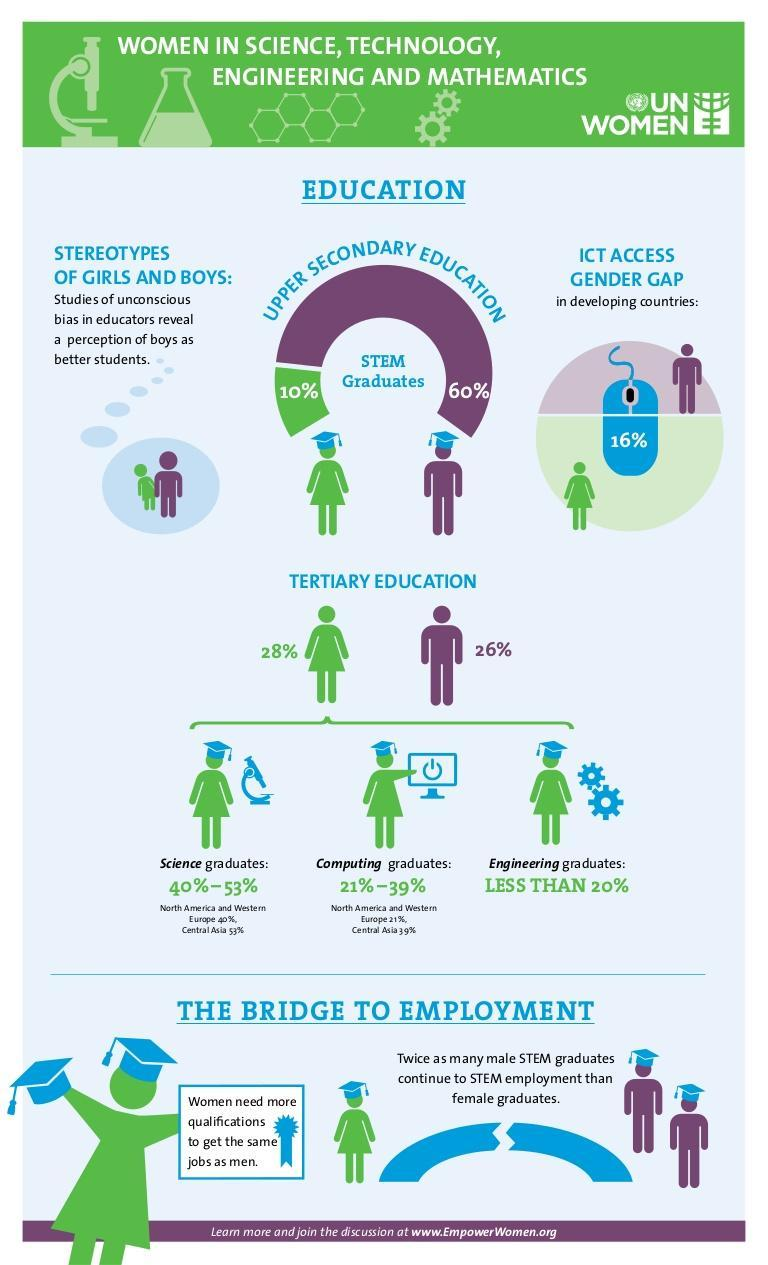What percentage of female science graduates are from Europe?
Answer the question with a short phrase. 40% What percent is the ICT access gender gap in developing countries? 16% What percent of women are stem graduates? 10% What percent of the female stem graduates are from the engineering background? LES THAN 20% What percent of men are stem graduates? 60% 